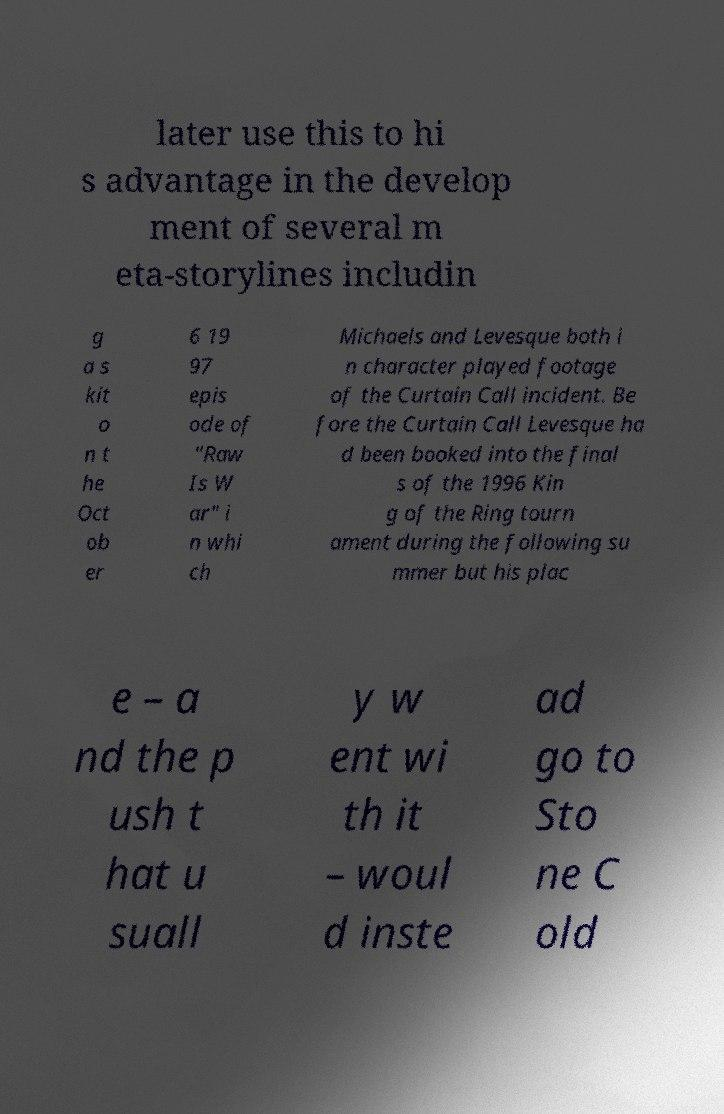For documentation purposes, I need the text within this image transcribed. Could you provide that? later use this to hi s advantage in the develop ment of several m eta-storylines includin g a s kit o n t he Oct ob er 6 19 97 epis ode of "Raw Is W ar" i n whi ch Michaels and Levesque both i n character played footage of the Curtain Call incident. Be fore the Curtain Call Levesque ha d been booked into the final s of the 1996 Kin g of the Ring tourn ament during the following su mmer but his plac e – a nd the p ush t hat u suall y w ent wi th it – woul d inste ad go to Sto ne C old 